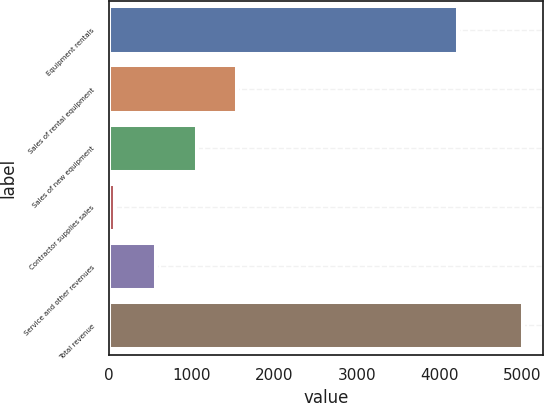Convert chart. <chart><loc_0><loc_0><loc_500><loc_500><bar_chart><fcel>Equipment rentals<fcel>Sales of rental equipment<fcel>Sales of new equipment<fcel>Contractor supplies sales<fcel>Service and other revenues<fcel>Total revenue<nl><fcel>4222<fcel>1551.7<fcel>1058.8<fcel>73<fcel>565.9<fcel>5002<nl></chart> 